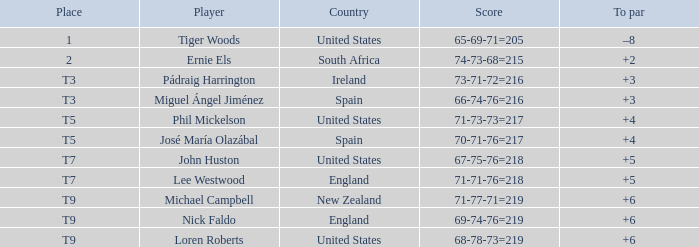What is To Par, when Place is "T5", and when Country is "United States"? 4.0. 